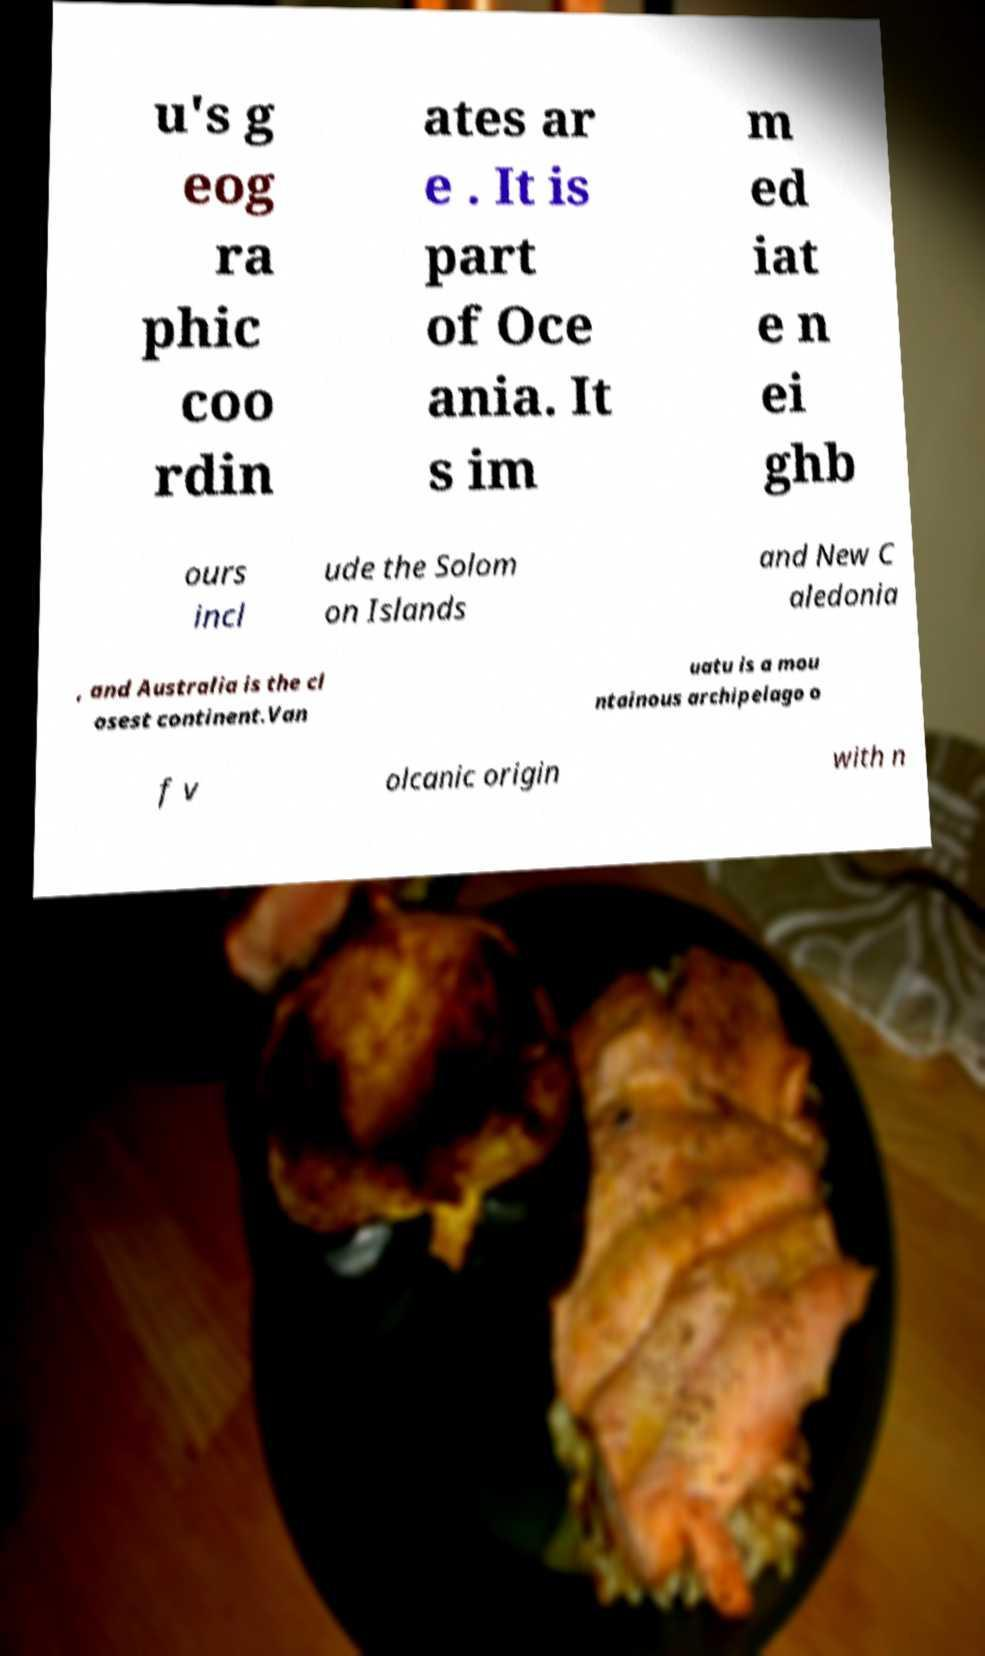I need the written content from this picture converted into text. Can you do that? u's g eog ra phic coo rdin ates ar e . It is part of Oce ania. It s im m ed iat e n ei ghb ours incl ude the Solom on Islands and New C aledonia , and Australia is the cl osest continent.Van uatu is a mou ntainous archipelago o f v olcanic origin with n 